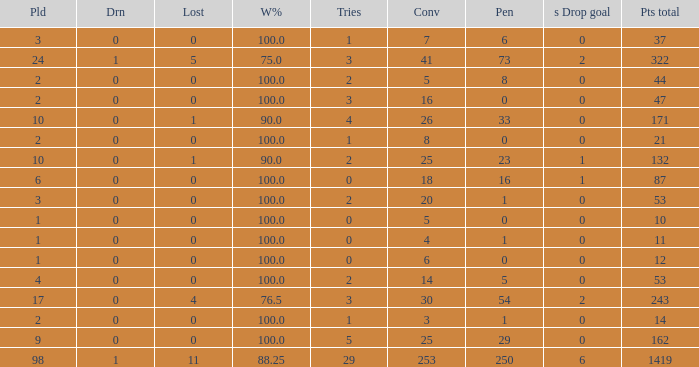What is the least number of penalties he got when his point total was over 1419 in more than 98 games? None. Parse the table in full. {'header': ['Pld', 'Drn', 'Lost', 'W%', 'Tries', 'Conv', 'Pen', 's Drop goal', 'Pts total'], 'rows': [['3', '0', '0', '100.0', '1', '7', '6', '0', '37'], ['24', '1', '5', '75.0', '3', '41', '73', '2', '322'], ['2', '0', '0', '100.0', '2', '5', '8', '0', '44'], ['2', '0', '0', '100.0', '3', '16', '0', '0', '47'], ['10', '0', '1', '90.0', '4', '26', '33', '0', '171'], ['2', '0', '0', '100.0', '1', '8', '0', '0', '21'], ['10', '0', '1', '90.0', '2', '25', '23', '1', '132'], ['6', '0', '0', '100.0', '0', '18', '16', '1', '87'], ['3', '0', '0', '100.0', '2', '20', '1', '0', '53'], ['1', '0', '0', '100.0', '0', '5', '0', '0', '10'], ['1', '0', '0', '100.0', '0', '4', '1', '0', '11'], ['1', '0', '0', '100.0', '0', '6', '0', '0', '12'], ['4', '0', '0', '100.0', '2', '14', '5', '0', '53'], ['17', '0', '4', '76.5', '3', '30', '54', '2', '243'], ['2', '0', '0', '100.0', '1', '3', '1', '0', '14'], ['9', '0', '0', '100.0', '5', '25', '29', '0', '162'], ['98', '1', '11', '88.25', '29', '253', '250', '6', '1419']]} 